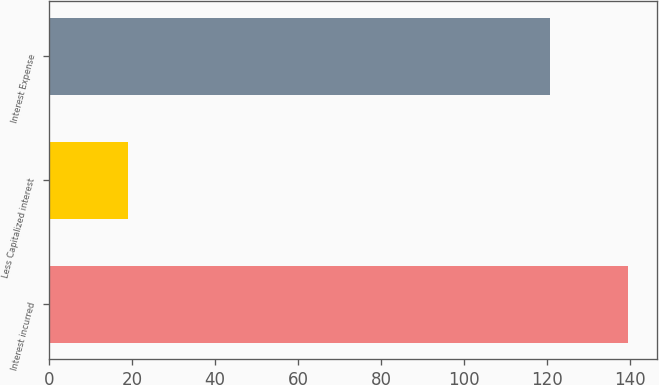<chart> <loc_0><loc_0><loc_500><loc_500><bar_chart><fcel>Interest incurred<fcel>Less Capitalized interest<fcel>Interest Expense<nl><fcel>139.6<fcel>19<fcel>120.6<nl></chart> 